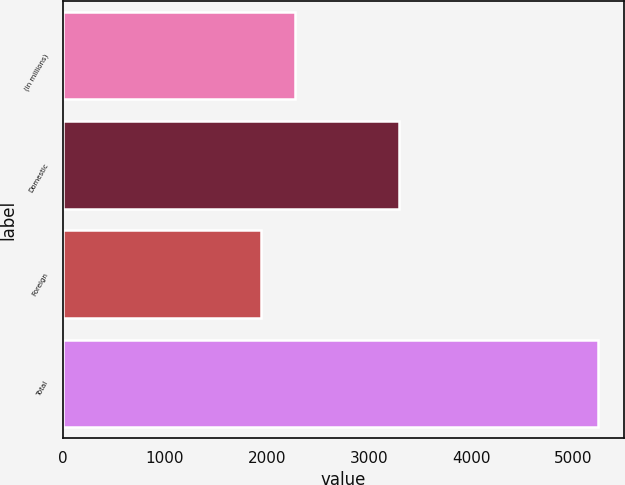Convert chart to OTSL. <chart><loc_0><loc_0><loc_500><loc_500><bar_chart><fcel>(in millions)<fcel>Domestic<fcel>Foreign<fcel>Total<nl><fcel>2271.8<fcel>3298<fcel>1942<fcel>5240<nl></chart> 